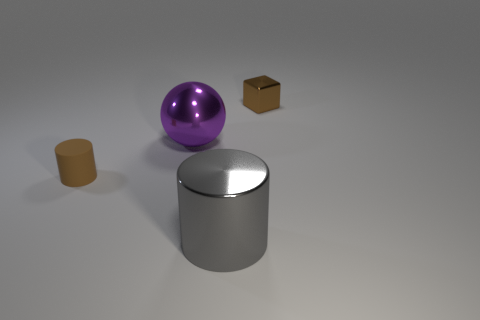There is a large shiny object that is on the left side of the gray thing; does it have the same shape as the small shiny thing?
Give a very brief answer. No. Are there any balls left of the large purple sphere?
Offer a terse response. No. What number of tiny objects are either purple shiny things or brown shiny spheres?
Ensure brevity in your answer.  0. Do the small brown cylinder and the big gray cylinder have the same material?
Your response must be concise. No. What size is the matte object that is the same color as the tiny shiny cube?
Provide a short and direct response. Small. Is there a metal ball of the same color as the tiny matte object?
Your answer should be compact. No. There is a cylinder that is the same material as the large purple sphere; what is its size?
Your answer should be very brief. Large. What is the shape of the big thing that is behind the brown object to the left of the tiny brown metal block behind the big gray shiny object?
Ensure brevity in your answer.  Sphere. The shiny object that is the same shape as the rubber thing is what size?
Offer a terse response. Large. How big is the object that is both in front of the purple thing and on the left side of the big gray cylinder?
Your answer should be very brief. Small. 